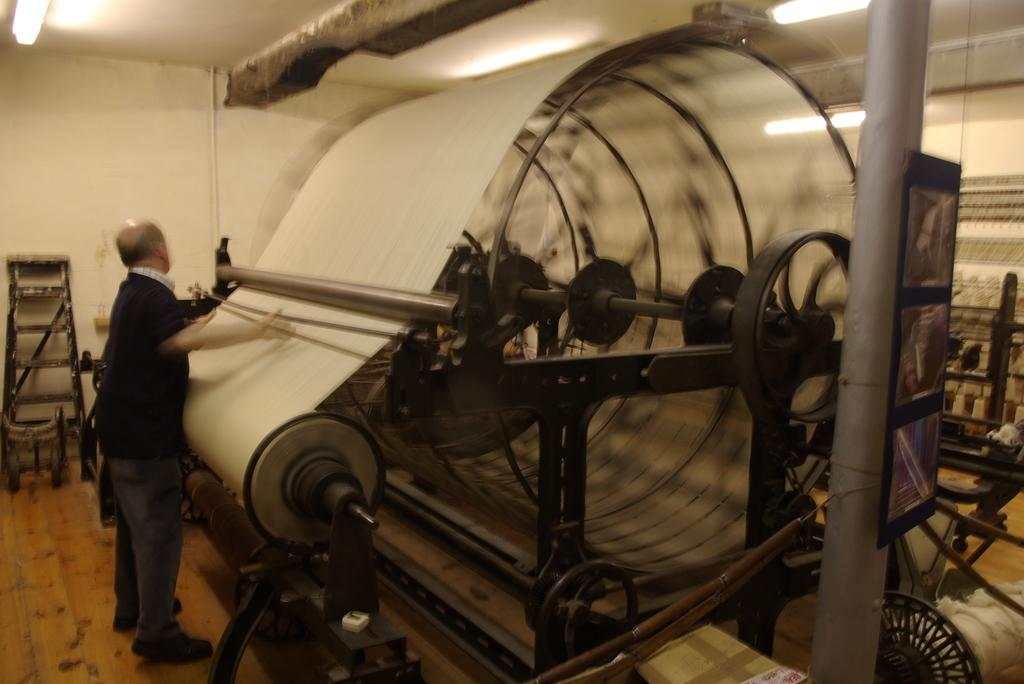What is the main object in the center of the image? There is a machine at the center of the image. Who or what is on the left side of the image? There is a man on the left side of the image. What can be seen at the top of the image? There are lights visible at the top of the image. What type of wood is used to build the machine in the image? There is no mention of wood being used to build the machine in the image, as it is likely made of metal or other materials. 